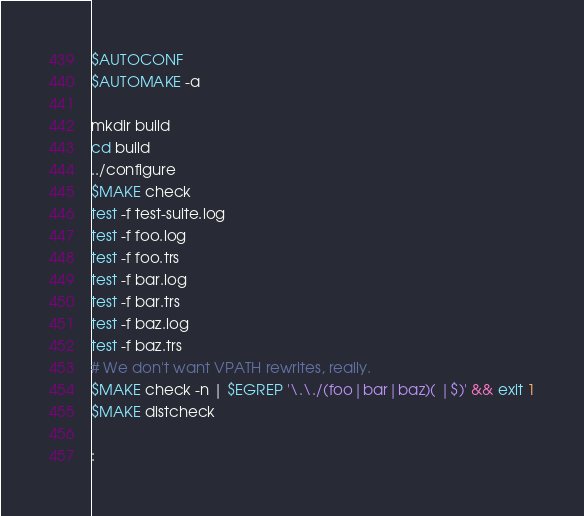<code> <loc_0><loc_0><loc_500><loc_500><_Bash_>$AUTOCONF
$AUTOMAKE -a

mkdir build
cd build
../configure
$MAKE check
test -f test-suite.log
test -f foo.log
test -f foo.trs
test -f bar.log
test -f bar.trs
test -f baz.log
test -f baz.trs
# We don't want VPATH rewrites, really.
$MAKE check -n | $EGREP '\.\./(foo|bar|baz)( |$)' && exit 1
$MAKE distcheck

:
</code> 